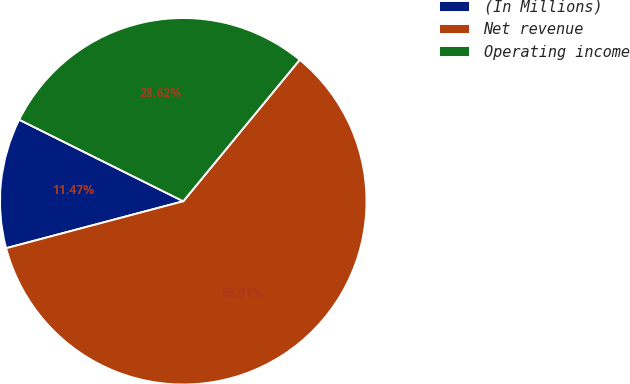Convert chart. <chart><loc_0><loc_0><loc_500><loc_500><pie_chart><fcel>(In Millions)<fcel>Net revenue<fcel>Operating income<nl><fcel>11.47%<fcel>59.92%<fcel>28.62%<nl></chart> 